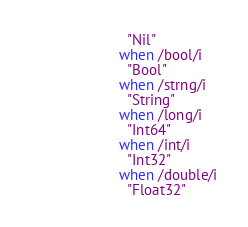Convert code to text. <code><loc_0><loc_0><loc_500><loc_500><_Crystal_>                        "Nil"
                      when /bool/i
                        "Bool"
                      when /strng/i
                        "String"
                      when /long/i
                        "Int64"
                      when /int/i
                        "Int32"
                      when /double/i
                        "Float32"</code> 